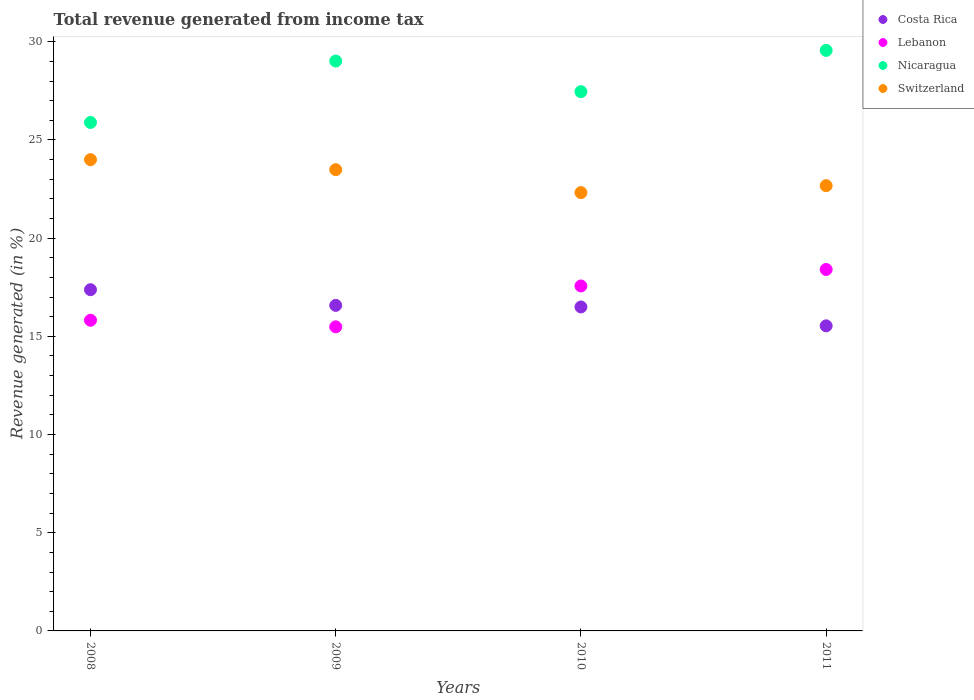What is the total revenue generated in Lebanon in 2010?
Make the answer very short. 17.57. Across all years, what is the maximum total revenue generated in Switzerland?
Provide a succinct answer. 24. Across all years, what is the minimum total revenue generated in Switzerland?
Your response must be concise. 22.32. In which year was the total revenue generated in Costa Rica maximum?
Make the answer very short. 2008. In which year was the total revenue generated in Costa Rica minimum?
Ensure brevity in your answer.  2011. What is the total total revenue generated in Lebanon in the graph?
Your answer should be very brief. 67.28. What is the difference between the total revenue generated in Nicaragua in 2008 and that in 2011?
Offer a terse response. -3.67. What is the difference between the total revenue generated in Lebanon in 2011 and the total revenue generated in Switzerland in 2010?
Keep it short and to the point. -3.91. What is the average total revenue generated in Costa Rica per year?
Make the answer very short. 16.5. In the year 2011, what is the difference between the total revenue generated in Nicaragua and total revenue generated in Switzerland?
Offer a terse response. 6.89. In how many years, is the total revenue generated in Costa Rica greater than 28 %?
Make the answer very short. 0. What is the ratio of the total revenue generated in Costa Rica in 2008 to that in 2011?
Provide a succinct answer. 1.12. Is the difference between the total revenue generated in Nicaragua in 2008 and 2010 greater than the difference between the total revenue generated in Switzerland in 2008 and 2010?
Keep it short and to the point. No. What is the difference between the highest and the second highest total revenue generated in Switzerland?
Ensure brevity in your answer.  0.51. What is the difference between the highest and the lowest total revenue generated in Switzerland?
Make the answer very short. 1.68. In how many years, is the total revenue generated in Switzerland greater than the average total revenue generated in Switzerland taken over all years?
Keep it short and to the point. 2. Is the sum of the total revenue generated in Switzerland in 2010 and 2011 greater than the maximum total revenue generated in Lebanon across all years?
Your answer should be compact. Yes. Is the total revenue generated in Costa Rica strictly greater than the total revenue generated in Nicaragua over the years?
Ensure brevity in your answer.  No. Is the total revenue generated in Switzerland strictly less than the total revenue generated in Costa Rica over the years?
Keep it short and to the point. No. Are the values on the major ticks of Y-axis written in scientific E-notation?
Offer a terse response. No. Does the graph contain any zero values?
Provide a short and direct response. No. Does the graph contain grids?
Offer a terse response. No. How are the legend labels stacked?
Give a very brief answer. Vertical. What is the title of the graph?
Your response must be concise. Total revenue generated from income tax. What is the label or title of the Y-axis?
Keep it short and to the point. Revenue generated (in %). What is the Revenue generated (in %) in Costa Rica in 2008?
Your answer should be very brief. 17.38. What is the Revenue generated (in %) of Lebanon in 2008?
Offer a very short reply. 15.82. What is the Revenue generated (in %) of Nicaragua in 2008?
Give a very brief answer. 25.89. What is the Revenue generated (in %) in Switzerland in 2008?
Provide a short and direct response. 24. What is the Revenue generated (in %) of Costa Rica in 2009?
Ensure brevity in your answer.  16.58. What is the Revenue generated (in %) in Lebanon in 2009?
Make the answer very short. 15.49. What is the Revenue generated (in %) of Nicaragua in 2009?
Your response must be concise. 29.02. What is the Revenue generated (in %) in Switzerland in 2009?
Provide a succinct answer. 23.49. What is the Revenue generated (in %) of Costa Rica in 2010?
Ensure brevity in your answer.  16.5. What is the Revenue generated (in %) in Lebanon in 2010?
Make the answer very short. 17.57. What is the Revenue generated (in %) of Nicaragua in 2010?
Your response must be concise. 27.46. What is the Revenue generated (in %) of Switzerland in 2010?
Provide a short and direct response. 22.32. What is the Revenue generated (in %) of Costa Rica in 2011?
Make the answer very short. 15.54. What is the Revenue generated (in %) in Lebanon in 2011?
Ensure brevity in your answer.  18.41. What is the Revenue generated (in %) of Nicaragua in 2011?
Your answer should be very brief. 29.56. What is the Revenue generated (in %) of Switzerland in 2011?
Your answer should be compact. 22.67. Across all years, what is the maximum Revenue generated (in %) of Costa Rica?
Provide a succinct answer. 17.38. Across all years, what is the maximum Revenue generated (in %) in Lebanon?
Your answer should be compact. 18.41. Across all years, what is the maximum Revenue generated (in %) of Nicaragua?
Ensure brevity in your answer.  29.56. Across all years, what is the maximum Revenue generated (in %) in Switzerland?
Provide a short and direct response. 24. Across all years, what is the minimum Revenue generated (in %) of Costa Rica?
Your answer should be very brief. 15.54. Across all years, what is the minimum Revenue generated (in %) in Lebanon?
Offer a terse response. 15.49. Across all years, what is the minimum Revenue generated (in %) in Nicaragua?
Your response must be concise. 25.89. Across all years, what is the minimum Revenue generated (in %) of Switzerland?
Offer a very short reply. 22.32. What is the total Revenue generated (in %) in Costa Rica in the graph?
Your response must be concise. 65.99. What is the total Revenue generated (in %) in Lebanon in the graph?
Offer a terse response. 67.28. What is the total Revenue generated (in %) of Nicaragua in the graph?
Give a very brief answer. 111.94. What is the total Revenue generated (in %) of Switzerland in the graph?
Offer a terse response. 92.48. What is the difference between the Revenue generated (in %) in Costa Rica in 2008 and that in 2009?
Offer a terse response. 0.8. What is the difference between the Revenue generated (in %) of Lebanon in 2008 and that in 2009?
Keep it short and to the point. 0.34. What is the difference between the Revenue generated (in %) of Nicaragua in 2008 and that in 2009?
Your answer should be compact. -3.13. What is the difference between the Revenue generated (in %) in Switzerland in 2008 and that in 2009?
Keep it short and to the point. 0.51. What is the difference between the Revenue generated (in %) of Costa Rica in 2008 and that in 2010?
Your answer should be compact. 0.88. What is the difference between the Revenue generated (in %) in Lebanon in 2008 and that in 2010?
Ensure brevity in your answer.  -1.75. What is the difference between the Revenue generated (in %) in Nicaragua in 2008 and that in 2010?
Provide a succinct answer. -1.57. What is the difference between the Revenue generated (in %) of Switzerland in 2008 and that in 2010?
Provide a short and direct response. 1.68. What is the difference between the Revenue generated (in %) in Costa Rica in 2008 and that in 2011?
Your response must be concise. 1.84. What is the difference between the Revenue generated (in %) of Lebanon in 2008 and that in 2011?
Your answer should be very brief. -2.59. What is the difference between the Revenue generated (in %) in Nicaragua in 2008 and that in 2011?
Offer a very short reply. -3.67. What is the difference between the Revenue generated (in %) in Switzerland in 2008 and that in 2011?
Provide a succinct answer. 1.33. What is the difference between the Revenue generated (in %) of Costa Rica in 2009 and that in 2010?
Offer a very short reply. 0.08. What is the difference between the Revenue generated (in %) in Lebanon in 2009 and that in 2010?
Provide a short and direct response. -2.08. What is the difference between the Revenue generated (in %) of Nicaragua in 2009 and that in 2010?
Offer a very short reply. 1.56. What is the difference between the Revenue generated (in %) of Switzerland in 2009 and that in 2010?
Offer a terse response. 1.17. What is the difference between the Revenue generated (in %) of Costa Rica in 2009 and that in 2011?
Offer a terse response. 1.04. What is the difference between the Revenue generated (in %) of Lebanon in 2009 and that in 2011?
Your answer should be compact. -2.92. What is the difference between the Revenue generated (in %) in Nicaragua in 2009 and that in 2011?
Your answer should be very brief. -0.54. What is the difference between the Revenue generated (in %) in Switzerland in 2009 and that in 2011?
Make the answer very short. 0.82. What is the difference between the Revenue generated (in %) in Costa Rica in 2010 and that in 2011?
Provide a succinct answer. 0.96. What is the difference between the Revenue generated (in %) in Lebanon in 2010 and that in 2011?
Offer a terse response. -0.84. What is the difference between the Revenue generated (in %) of Nicaragua in 2010 and that in 2011?
Make the answer very short. -2.1. What is the difference between the Revenue generated (in %) of Switzerland in 2010 and that in 2011?
Your answer should be compact. -0.35. What is the difference between the Revenue generated (in %) of Costa Rica in 2008 and the Revenue generated (in %) of Lebanon in 2009?
Offer a very short reply. 1.89. What is the difference between the Revenue generated (in %) in Costa Rica in 2008 and the Revenue generated (in %) in Nicaragua in 2009?
Your response must be concise. -11.64. What is the difference between the Revenue generated (in %) in Costa Rica in 2008 and the Revenue generated (in %) in Switzerland in 2009?
Provide a succinct answer. -6.11. What is the difference between the Revenue generated (in %) of Lebanon in 2008 and the Revenue generated (in %) of Nicaragua in 2009?
Keep it short and to the point. -13.2. What is the difference between the Revenue generated (in %) in Lebanon in 2008 and the Revenue generated (in %) in Switzerland in 2009?
Your answer should be very brief. -7.67. What is the difference between the Revenue generated (in %) of Nicaragua in 2008 and the Revenue generated (in %) of Switzerland in 2009?
Your response must be concise. 2.4. What is the difference between the Revenue generated (in %) in Costa Rica in 2008 and the Revenue generated (in %) in Lebanon in 2010?
Make the answer very short. -0.19. What is the difference between the Revenue generated (in %) in Costa Rica in 2008 and the Revenue generated (in %) in Nicaragua in 2010?
Your response must be concise. -10.09. What is the difference between the Revenue generated (in %) of Costa Rica in 2008 and the Revenue generated (in %) of Switzerland in 2010?
Give a very brief answer. -4.94. What is the difference between the Revenue generated (in %) in Lebanon in 2008 and the Revenue generated (in %) in Nicaragua in 2010?
Your answer should be compact. -11.64. What is the difference between the Revenue generated (in %) in Lebanon in 2008 and the Revenue generated (in %) in Switzerland in 2010?
Your response must be concise. -6.5. What is the difference between the Revenue generated (in %) of Nicaragua in 2008 and the Revenue generated (in %) of Switzerland in 2010?
Keep it short and to the point. 3.57. What is the difference between the Revenue generated (in %) of Costa Rica in 2008 and the Revenue generated (in %) of Lebanon in 2011?
Your answer should be compact. -1.03. What is the difference between the Revenue generated (in %) of Costa Rica in 2008 and the Revenue generated (in %) of Nicaragua in 2011?
Provide a succinct answer. -12.19. What is the difference between the Revenue generated (in %) in Costa Rica in 2008 and the Revenue generated (in %) in Switzerland in 2011?
Provide a succinct answer. -5.3. What is the difference between the Revenue generated (in %) in Lebanon in 2008 and the Revenue generated (in %) in Nicaragua in 2011?
Your answer should be very brief. -13.74. What is the difference between the Revenue generated (in %) of Lebanon in 2008 and the Revenue generated (in %) of Switzerland in 2011?
Offer a terse response. -6.85. What is the difference between the Revenue generated (in %) of Nicaragua in 2008 and the Revenue generated (in %) of Switzerland in 2011?
Offer a very short reply. 3.22. What is the difference between the Revenue generated (in %) in Costa Rica in 2009 and the Revenue generated (in %) in Lebanon in 2010?
Offer a very short reply. -0.99. What is the difference between the Revenue generated (in %) in Costa Rica in 2009 and the Revenue generated (in %) in Nicaragua in 2010?
Offer a terse response. -10.88. What is the difference between the Revenue generated (in %) in Costa Rica in 2009 and the Revenue generated (in %) in Switzerland in 2010?
Provide a succinct answer. -5.74. What is the difference between the Revenue generated (in %) of Lebanon in 2009 and the Revenue generated (in %) of Nicaragua in 2010?
Give a very brief answer. -11.98. What is the difference between the Revenue generated (in %) in Lebanon in 2009 and the Revenue generated (in %) in Switzerland in 2010?
Provide a succinct answer. -6.84. What is the difference between the Revenue generated (in %) in Nicaragua in 2009 and the Revenue generated (in %) in Switzerland in 2010?
Provide a short and direct response. 6.7. What is the difference between the Revenue generated (in %) in Costa Rica in 2009 and the Revenue generated (in %) in Lebanon in 2011?
Your answer should be compact. -1.83. What is the difference between the Revenue generated (in %) in Costa Rica in 2009 and the Revenue generated (in %) in Nicaragua in 2011?
Your response must be concise. -12.99. What is the difference between the Revenue generated (in %) in Costa Rica in 2009 and the Revenue generated (in %) in Switzerland in 2011?
Make the answer very short. -6.1. What is the difference between the Revenue generated (in %) in Lebanon in 2009 and the Revenue generated (in %) in Nicaragua in 2011?
Your answer should be compact. -14.08. What is the difference between the Revenue generated (in %) in Lebanon in 2009 and the Revenue generated (in %) in Switzerland in 2011?
Offer a very short reply. -7.19. What is the difference between the Revenue generated (in %) of Nicaragua in 2009 and the Revenue generated (in %) of Switzerland in 2011?
Your answer should be very brief. 6.35. What is the difference between the Revenue generated (in %) of Costa Rica in 2010 and the Revenue generated (in %) of Lebanon in 2011?
Provide a short and direct response. -1.91. What is the difference between the Revenue generated (in %) in Costa Rica in 2010 and the Revenue generated (in %) in Nicaragua in 2011?
Ensure brevity in your answer.  -13.06. What is the difference between the Revenue generated (in %) in Costa Rica in 2010 and the Revenue generated (in %) in Switzerland in 2011?
Ensure brevity in your answer.  -6.18. What is the difference between the Revenue generated (in %) of Lebanon in 2010 and the Revenue generated (in %) of Nicaragua in 2011?
Give a very brief answer. -12. What is the difference between the Revenue generated (in %) of Lebanon in 2010 and the Revenue generated (in %) of Switzerland in 2011?
Provide a succinct answer. -5.11. What is the difference between the Revenue generated (in %) in Nicaragua in 2010 and the Revenue generated (in %) in Switzerland in 2011?
Provide a short and direct response. 4.79. What is the average Revenue generated (in %) of Costa Rica per year?
Provide a succinct answer. 16.5. What is the average Revenue generated (in %) in Lebanon per year?
Your answer should be very brief. 16.82. What is the average Revenue generated (in %) of Nicaragua per year?
Provide a succinct answer. 27.98. What is the average Revenue generated (in %) in Switzerland per year?
Your answer should be very brief. 23.12. In the year 2008, what is the difference between the Revenue generated (in %) in Costa Rica and Revenue generated (in %) in Lebanon?
Your answer should be very brief. 1.56. In the year 2008, what is the difference between the Revenue generated (in %) of Costa Rica and Revenue generated (in %) of Nicaragua?
Provide a short and direct response. -8.52. In the year 2008, what is the difference between the Revenue generated (in %) in Costa Rica and Revenue generated (in %) in Switzerland?
Your response must be concise. -6.62. In the year 2008, what is the difference between the Revenue generated (in %) of Lebanon and Revenue generated (in %) of Nicaragua?
Make the answer very short. -10.07. In the year 2008, what is the difference between the Revenue generated (in %) in Lebanon and Revenue generated (in %) in Switzerland?
Your answer should be compact. -8.18. In the year 2008, what is the difference between the Revenue generated (in %) of Nicaragua and Revenue generated (in %) of Switzerland?
Provide a short and direct response. 1.89. In the year 2009, what is the difference between the Revenue generated (in %) of Costa Rica and Revenue generated (in %) of Lebanon?
Offer a terse response. 1.09. In the year 2009, what is the difference between the Revenue generated (in %) of Costa Rica and Revenue generated (in %) of Nicaragua?
Make the answer very short. -12.44. In the year 2009, what is the difference between the Revenue generated (in %) of Costa Rica and Revenue generated (in %) of Switzerland?
Your answer should be very brief. -6.91. In the year 2009, what is the difference between the Revenue generated (in %) in Lebanon and Revenue generated (in %) in Nicaragua?
Your response must be concise. -13.54. In the year 2009, what is the difference between the Revenue generated (in %) in Lebanon and Revenue generated (in %) in Switzerland?
Your answer should be compact. -8. In the year 2009, what is the difference between the Revenue generated (in %) in Nicaragua and Revenue generated (in %) in Switzerland?
Provide a short and direct response. 5.53. In the year 2010, what is the difference between the Revenue generated (in %) of Costa Rica and Revenue generated (in %) of Lebanon?
Provide a short and direct response. -1.07. In the year 2010, what is the difference between the Revenue generated (in %) in Costa Rica and Revenue generated (in %) in Nicaragua?
Give a very brief answer. -10.96. In the year 2010, what is the difference between the Revenue generated (in %) in Costa Rica and Revenue generated (in %) in Switzerland?
Keep it short and to the point. -5.82. In the year 2010, what is the difference between the Revenue generated (in %) of Lebanon and Revenue generated (in %) of Nicaragua?
Provide a short and direct response. -9.89. In the year 2010, what is the difference between the Revenue generated (in %) in Lebanon and Revenue generated (in %) in Switzerland?
Your answer should be very brief. -4.75. In the year 2010, what is the difference between the Revenue generated (in %) in Nicaragua and Revenue generated (in %) in Switzerland?
Give a very brief answer. 5.14. In the year 2011, what is the difference between the Revenue generated (in %) in Costa Rica and Revenue generated (in %) in Lebanon?
Keep it short and to the point. -2.87. In the year 2011, what is the difference between the Revenue generated (in %) in Costa Rica and Revenue generated (in %) in Nicaragua?
Your answer should be compact. -14.03. In the year 2011, what is the difference between the Revenue generated (in %) of Costa Rica and Revenue generated (in %) of Switzerland?
Offer a very short reply. -7.14. In the year 2011, what is the difference between the Revenue generated (in %) of Lebanon and Revenue generated (in %) of Nicaragua?
Provide a succinct answer. -11.16. In the year 2011, what is the difference between the Revenue generated (in %) in Lebanon and Revenue generated (in %) in Switzerland?
Ensure brevity in your answer.  -4.27. In the year 2011, what is the difference between the Revenue generated (in %) in Nicaragua and Revenue generated (in %) in Switzerland?
Your response must be concise. 6.89. What is the ratio of the Revenue generated (in %) in Costa Rica in 2008 to that in 2009?
Ensure brevity in your answer.  1.05. What is the ratio of the Revenue generated (in %) in Lebanon in 2008 to that in 2009?
Your answer should be compact. 1.02. What is the ratio of the Revenue generated (in %) of Nicaragua in 2008 to that in 2009?
Ensure brevity in your answer.  0.89. What is the ratio of the Revenue generated (in %) in Switzerland in 2008 to that in 2009?
Offer a very short reply. 1.02. What is the ratio of the Revenue generated (in %) of Costa Rica in 2008 to that in 2010?
Give a very brief answer. 1.05. What is the ratio of the Revenue generated (in %) in Lebanon in 2008 to that in 2010?
Offer a very short reply. 0.9. What is the ratio of the Revenue generated (in %) in Nicaragua in 2008 to that in 2010?
Keep it short and to the point. 0.94. What is the ratio of the Revenue generated (in %) of Switzerland in 2008 to that in 2010?
Provide a short and direct response. 1.08. What is the ratio of the Revenue generated (in %) of Costa Rica in 2008 to that in 2011?
Provide a succinct answer. 1.12. What is the ratio of the Revenue generated (in %) of Lebanon in 2008 to that in 2011?
Keep it short and to the point. 0.86. What is the ratio of the Revenue generated (in %) in Nicaragua in 2008 to that in 2011?
Offer a terse response. 0.88. What is the ratio of the Revenue generated (in %) of Switzerland in 2008 to that in 2011?
Your response must be concise. 1.06. What is the ratio of the Revenue generated (in %) of Costa Rica in 2009 to that in 2010?
Make the answer very short. 1. What is the ratio of the Revenue generated (in %) of Lebanon in 2009 to that in 2010?
Make the answer very short. 0.88. What is the ratio of the Revenue generated (in %) in Nicaragua in 2009 to that in 2010?
Your answer should be compact. 1.06. What is the ratio of the Revenue generated (in %) in Switzerland in 2009 to that in 2010?
Provide a short and direct response. 1.05. What is the ratio of the Revenue generated (in %) of Costa Rica in 2009 to that in 2011?
Your response must be concise. 1.07. What is the ratio of the Revenue generated (in %) of Lebanon in 2009 to that in 2011?
Offer a very short reply. 0.84. What is the ratio of the Revenue generated (in %) of Nicaragua in 2009 to that in 2011?
Give a very brief answer. 0.98. What is the ratio of the Revenue generated (in %) in Switzerland in 2009 to that in 2011?
Offer a terse response. 1.04. What is the ratio of the Revenue generated (in %) of Costa Rica in 2010 to that in 2011?
Your answer should be very brief. 1.06. What is the ratio of the Revenue generated (in %) in Lebanon in 2010 to that in 2011?
Your response must be concise. 0.95. What is the ratio of the Revenue generated (in %) in Nicaragua in 2010 to that in 2011?
Provide a short and direct response. 0.93. What is the ratio of the Revenue generated (in %) in Switzerland in 2010 to that in 2011?
Ensure brevity in your answer.  0.98. What is the difference between the highest and the second highest Revenue generated (in %) of Costa Rica?
Keep it short and to the point. 0.8. What is the difference between the highest and the second highest Revenue generated (in %) of Lebanon?
Your answer should be compact. 0.84. What is the difference between the highest and the second highest Revenue generated (in %) of Nicaragua?
Make the answer very short. 0.54. What is the difference between the highest and the second highest Revenue generated (in %) of Switzerland?
Make the answer very short. 0.51. What is the difference between the highest and the lowest Revenue generated (in %) of Costa Rica?
Ensure brevity in your answer.  1.84. What is the difference between the highest and the lowest Revenue generated (in %) of Lebanon?
Your answer should be very brief. 2.92. What is the difference between the highest and the lowest Revenue generated (in %) of Nicaragua?
Provide a short and direct response. 3.67. What is the difference between the highest and the lowest Revenue generated (in %) of Switzerland?
Provide a succinct answer. 1.68. 